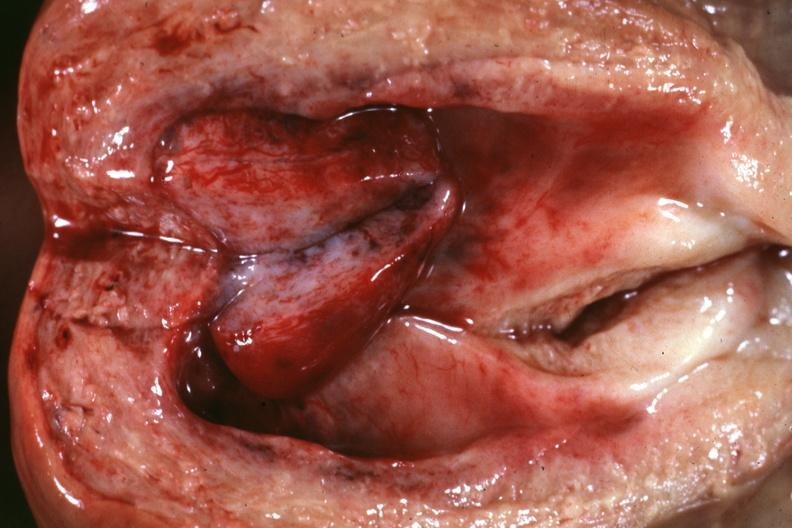what is present?
Answer the question using a single word or phrase. Endometrial polyp 